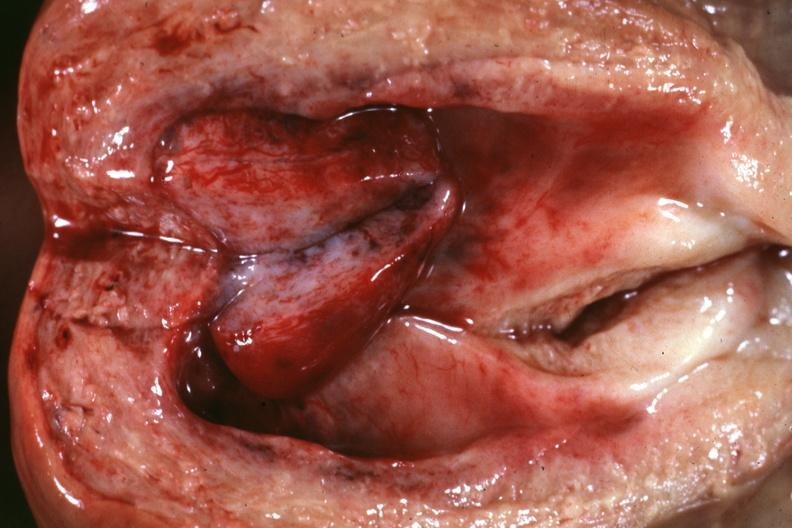what is present?
Answer the question using a single word or phrase. Endometrial polyp 